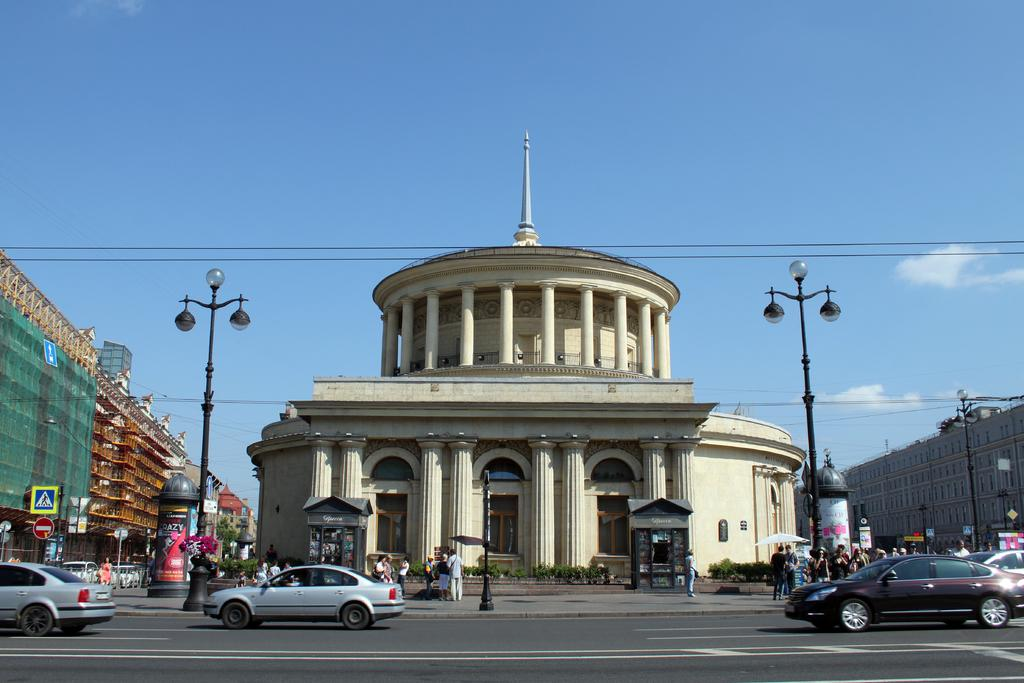What is the main structure in the center of the image? There is a building in the center of the image. What type of vehicles can be seen at the bottom side of the image? There are cars at the bottom side of the image. Where are the people located in the image? There are people on both the right and left sides of the image. What color is the sweater worn by the person folding laundry in the image? There is no person folding laundry in the image, and no sweater is mentioned in the provided facts. 